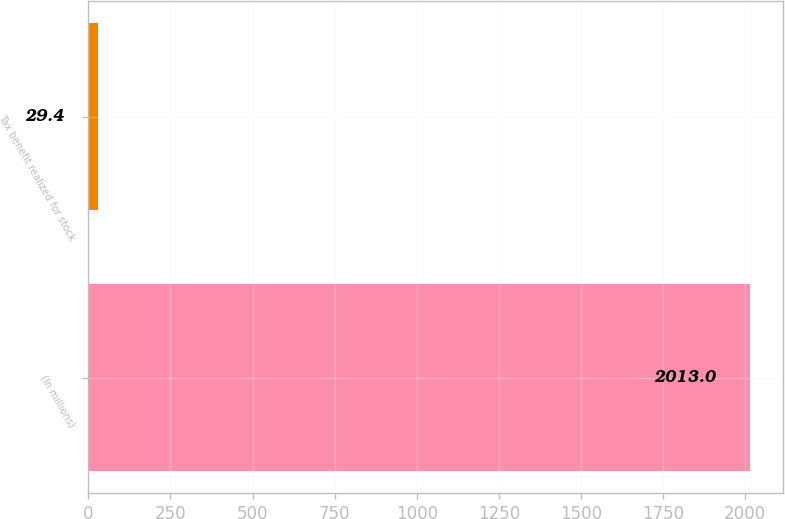Convert chart. <chart><loc_0><loc_0><loc_500><loc_500><bar_chart><fcel>(In millions)<fcel>Tax benefit realized for stock<nl><fcel>2013<fcel>29.4<nl></chart> 